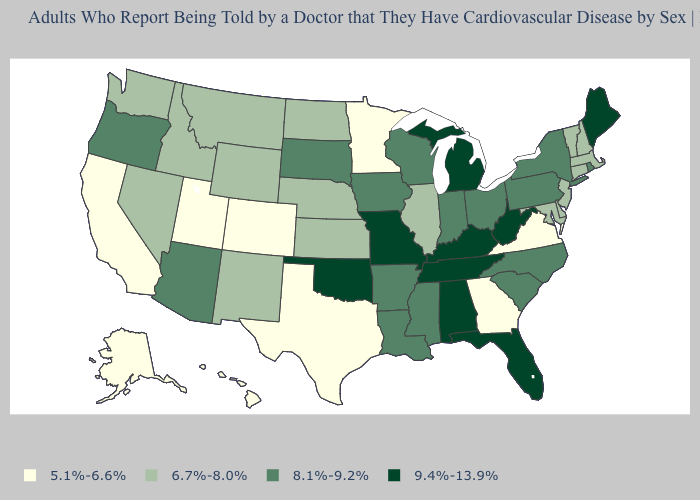Does North Carolina have a lower value than Tennessee?
Be succinct. Yes. What is the lowest value in the MidWest?
Give a very brief answer. 5.1%-6.6%. What is the value of South Dakota?
Quick response, please. 8.1%-9.2%. What is the value of Utah?
Give a very brief answer. 5.1%-6.6%. What is the value of Iowa?
Write a very short answer. 8.1%-9.2%. What is the value of Florida?
Be succinct. 9.4%-13.9%. Does Kentucky have the highest value in the USA?
Concise answer only. Yes. Name the states that have a value in the range 8.1%-9.2%?
Write a very short answer. Arizona, Arkansas, Indiana, Iowa, Louisiana, Mississippi, New York, North Carolina, Ohio, Oregon, Pennsylvania, Rhode Island, South Carolina, South Dakota, Wisconsin. Is the legend a continuous bar?
Give a very brief answer. No. What is the highest value in the USA?
Answer briefly. 9.4%-13.9%. Does the map have missing data?
Give a very brief answer. No. Among the states that border Florida , does Georgia have the highest value?
Be succinct. No. Among the states that border West Virginia , does Ohio have the highest value?
Concise answer only. No. Name the states that have a value in the range 8.1%-9.2%?
Short answer required. Arizona, Arkansas, Indiana, Iowa, Louisiana, Mississippi, New York, North Carolina, Ohio, Oregon, Pennsylvania, Rhode Island, South Carolina, South Dakota, Wisconsin. 